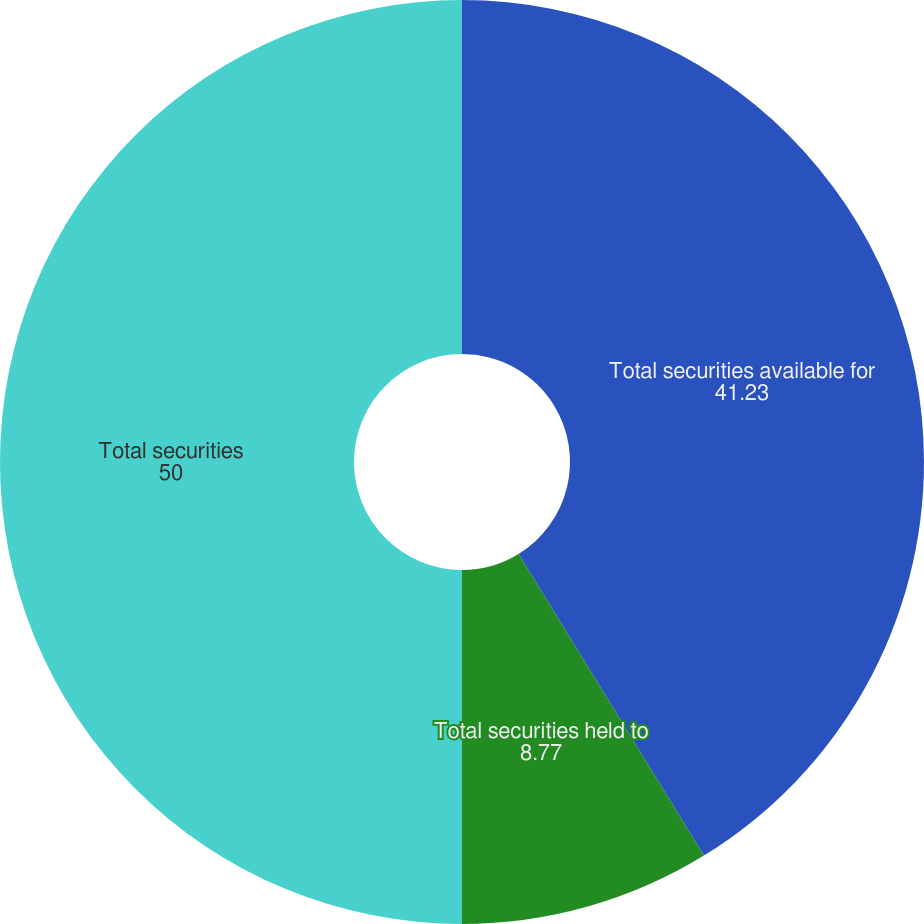Convert chart. <chart><loc_0><loc_0><loc_500><loc_500><pie_chart><fcel>Total securities available for<fcel>Total securities held to<fcel>Total securities<nl><fcel>41.23%<fcel>8.77%<fcel>50.0%<nl></chart> 